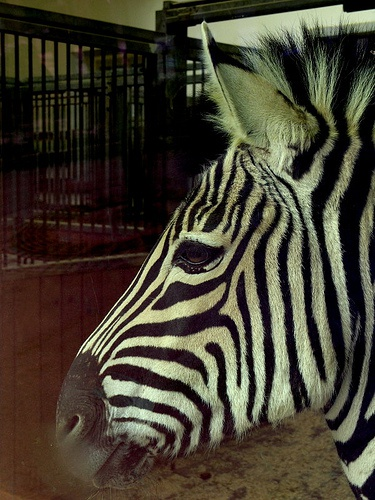Describe the objects in this image and their specific colors. I can see a zebra in darkgreen, black, gray, olive, and darkgray tones in this image. 